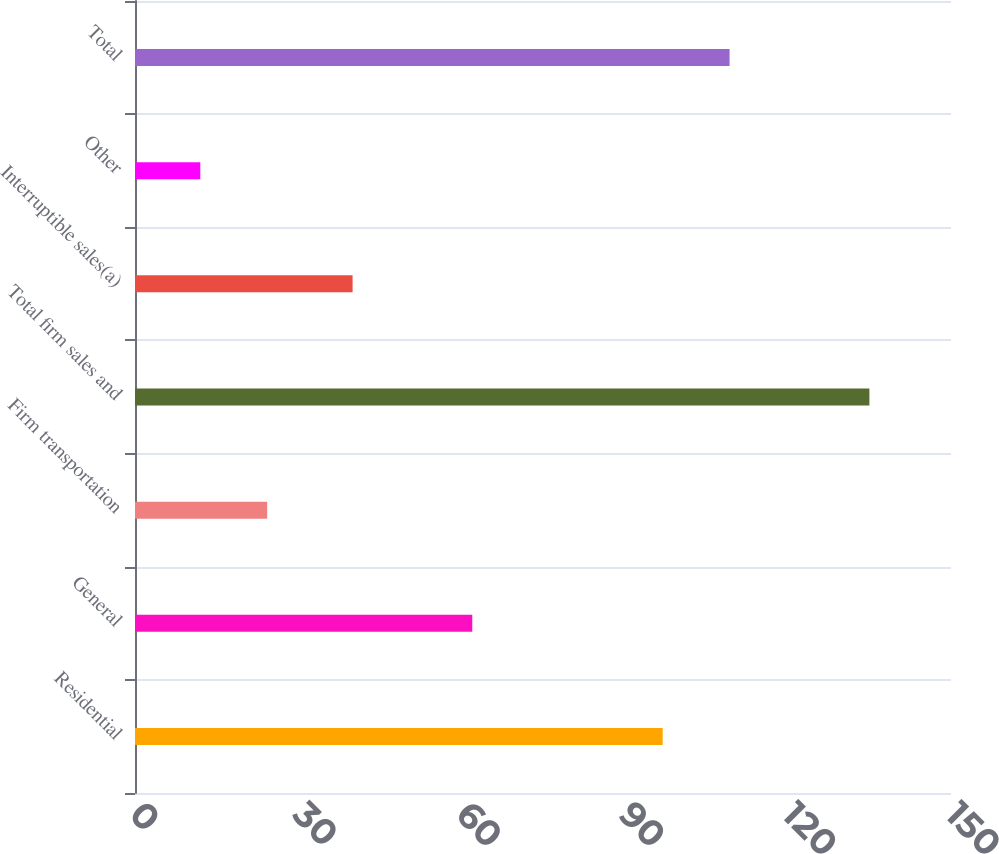Convert chart to OTSL. <chart><loc_0><loc_0><loc_500><loc_500><bar_chart><fcel>Residential<fcel>General<fcel>Firm transportation<fcel>Total firm sales and<fcel>Interruptible sales(a)<fcel>Other<fcel>Total<nl><fcel>97<fcel>62<fcel>24.3<fcel>135<fcel>40<fcel>12<fcel>109.3<nl></chart> 